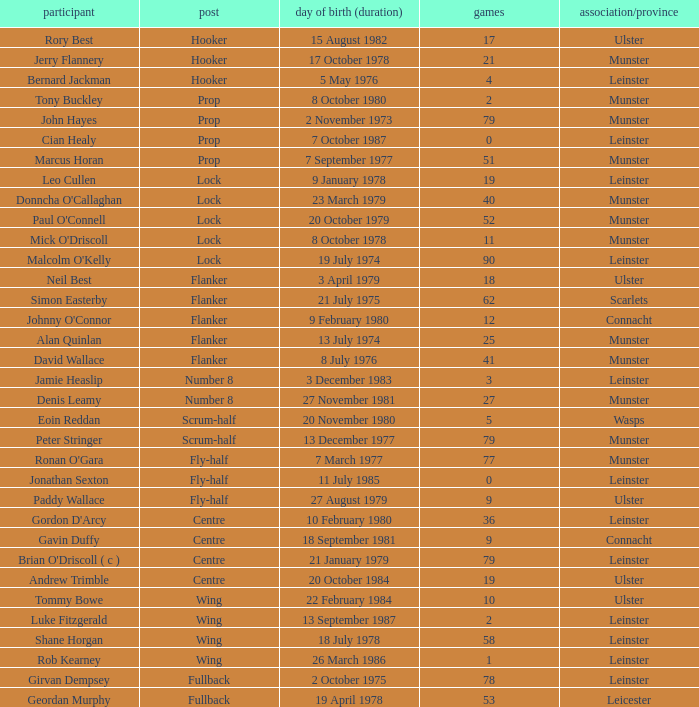What Club/province have caps less than 2 and Jonathan Sexton as player? Leinster. 